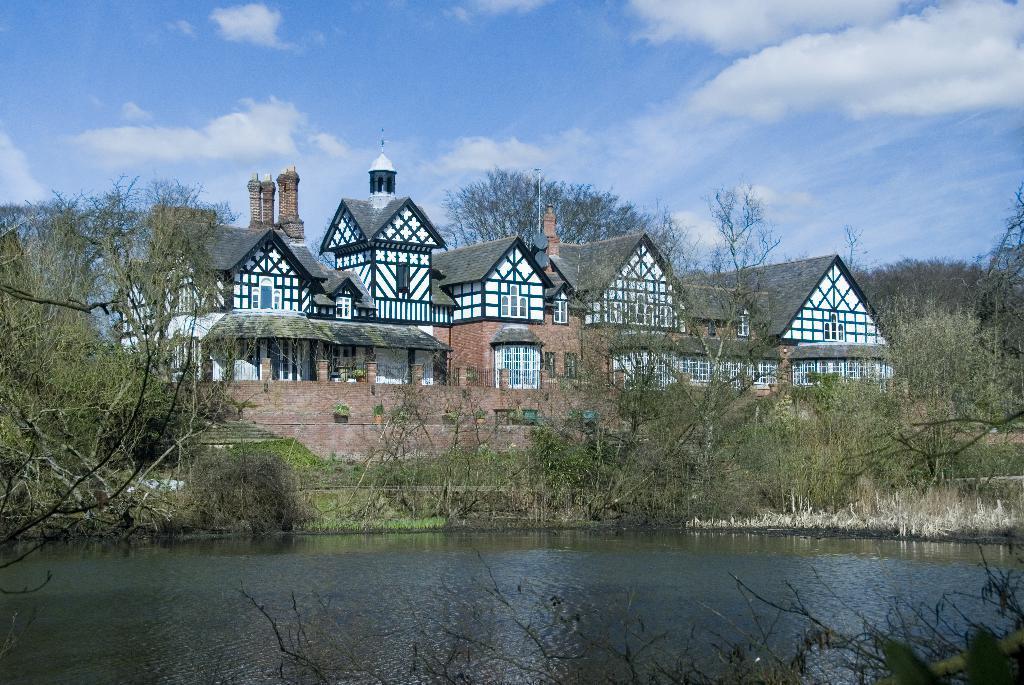How would you summarize this image in a sentence or two? In this image I can see a building. There are plants, trees, there is grass and in the background there is sky. 